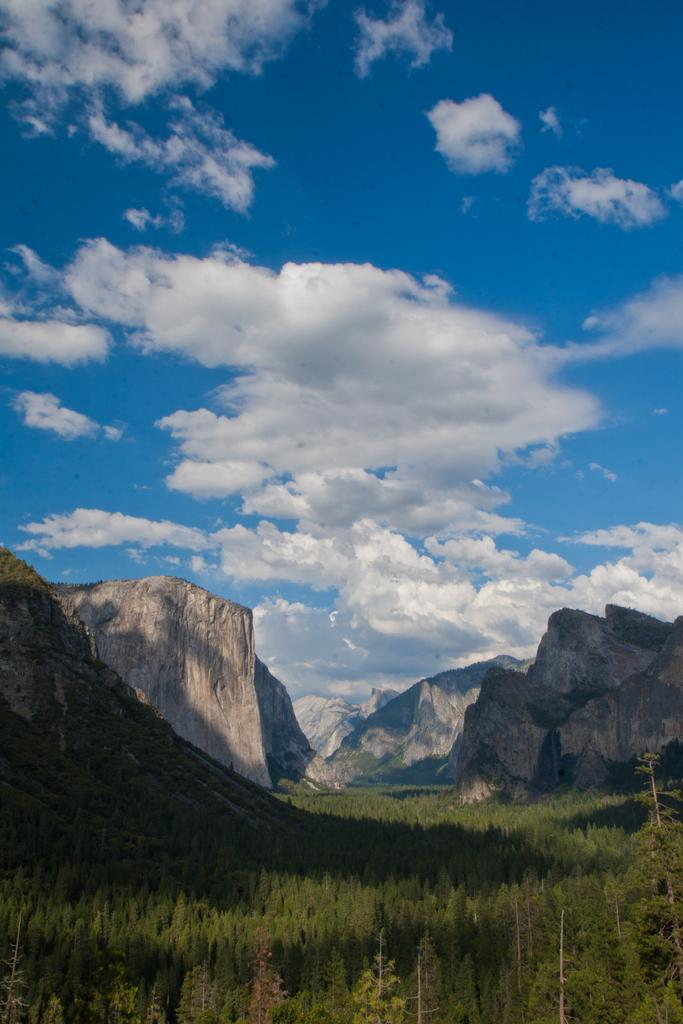What celestial bodies are depicted in the image? There are planets in the image. What type of geographical feature can be seen in the image? There are hills in the image. What is visible in the background of the image? The sky is visible in the background of the image. How many slaves can be seen working on the hills in the image? There are no slaves or any human figures present in the image; it features planets and hills. What type of fruit is being picked by the people on the hills in the image? There are no people or fruit depicted in the image; it features planets and hills. 